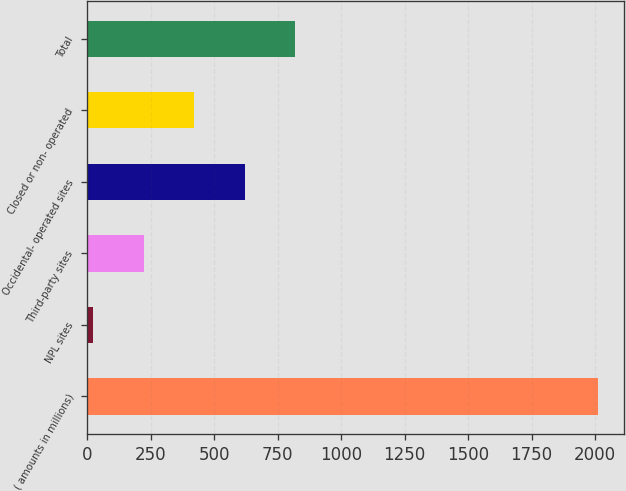<chart> <loc_0><loc_0><loc_500><loc_500><bar_chart><fcel>( amounts in millions)<fcel>NPL sites<fcel>Third-party sites<fcel>Occidental- operated sites<fcel>Closed or non- operated<fcel>Total<nl><fcel>2013<fcel>25<fcel>223.8<fcel>621.4<fcel>422.6<fcel>820.2<nl></chart> 